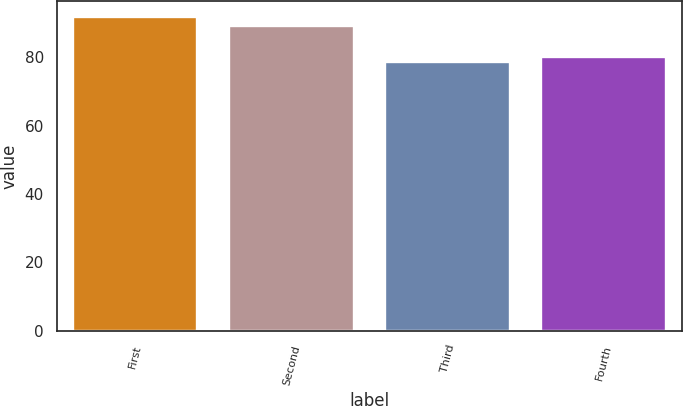Convert chart. <chart><loc_0><loc_0><loc_500><loc_500><bar_chart><fcel>First<fcel>Second<fcel>Third<fcel>Fourth<nl><fcel>91.74<fcel>89.17<fcel>78.76<fcel>80.06<nl></chart> 